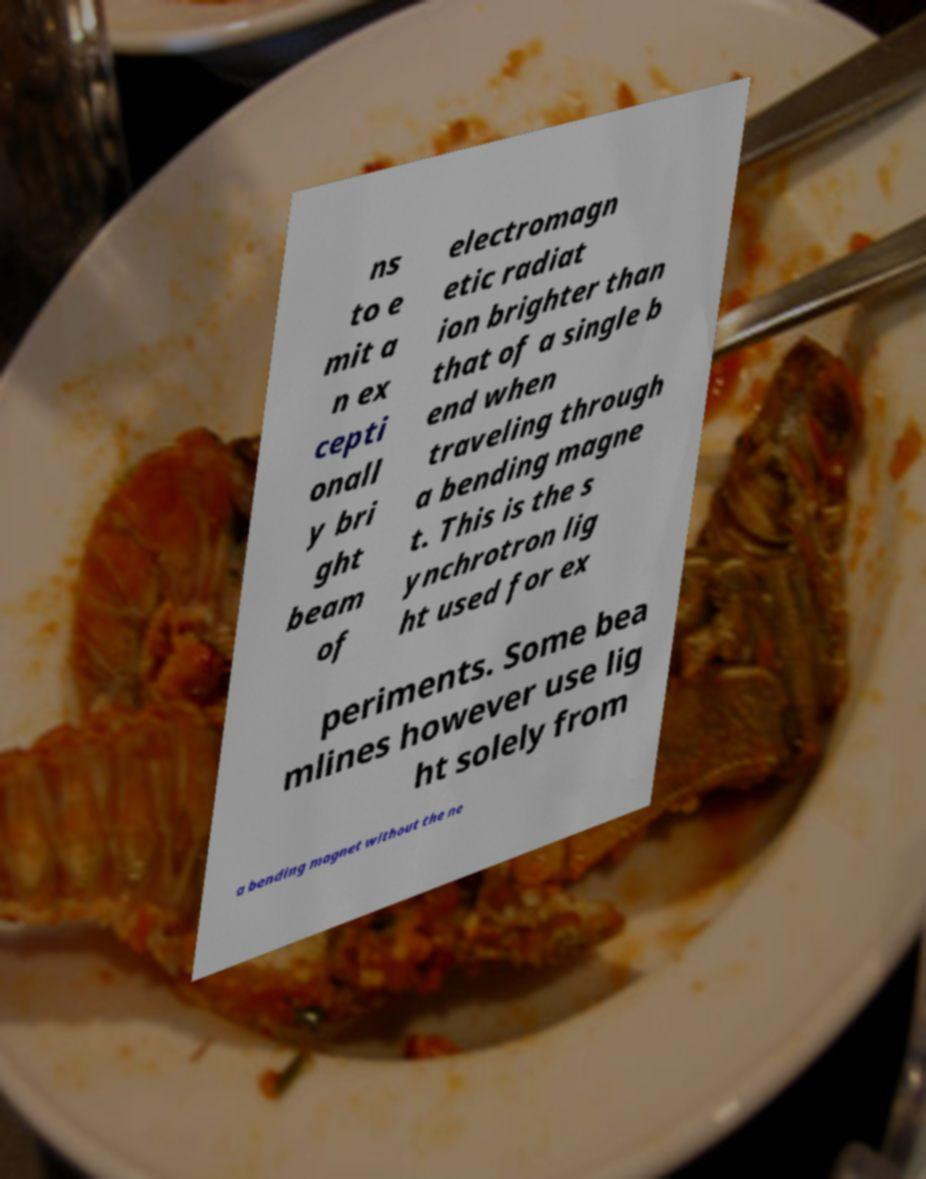I need the written content from this picture converted into text. Can you do that? ns to e mit a n ex cepti onall y bri ght beam of electromagn etic radiat ion brighter than that of a single b end when traveling through a bending magne t. This is the s ynchrotron lig ht used for ex periments. Some bea mlines however use lig ht solely from a bending magnet without the ne 